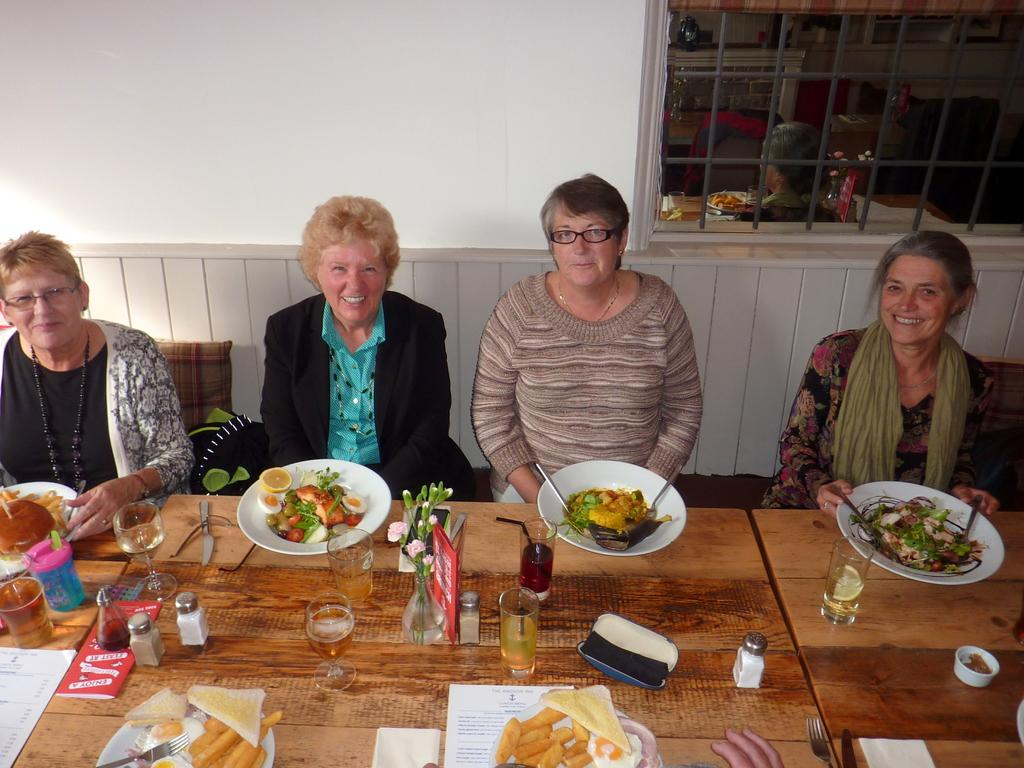What is the color of the wall in the image? The wall in the image is white. What can be seen on the wall in the image? There is a window on the wall in the image. What are the people in the image doing? The people are sitting on a bench in the image. What is on the table in the image? There is a table in the image with plates, glasses, bowls, forks, and food items. How many icicles are hanging from the window in the image? There are no icicles present in the image; it is a white wall with a window. What type of flock is depicted in the image? There is no flock depicted in the image; it features a white wall, a window, a bench, and a table with various items. 